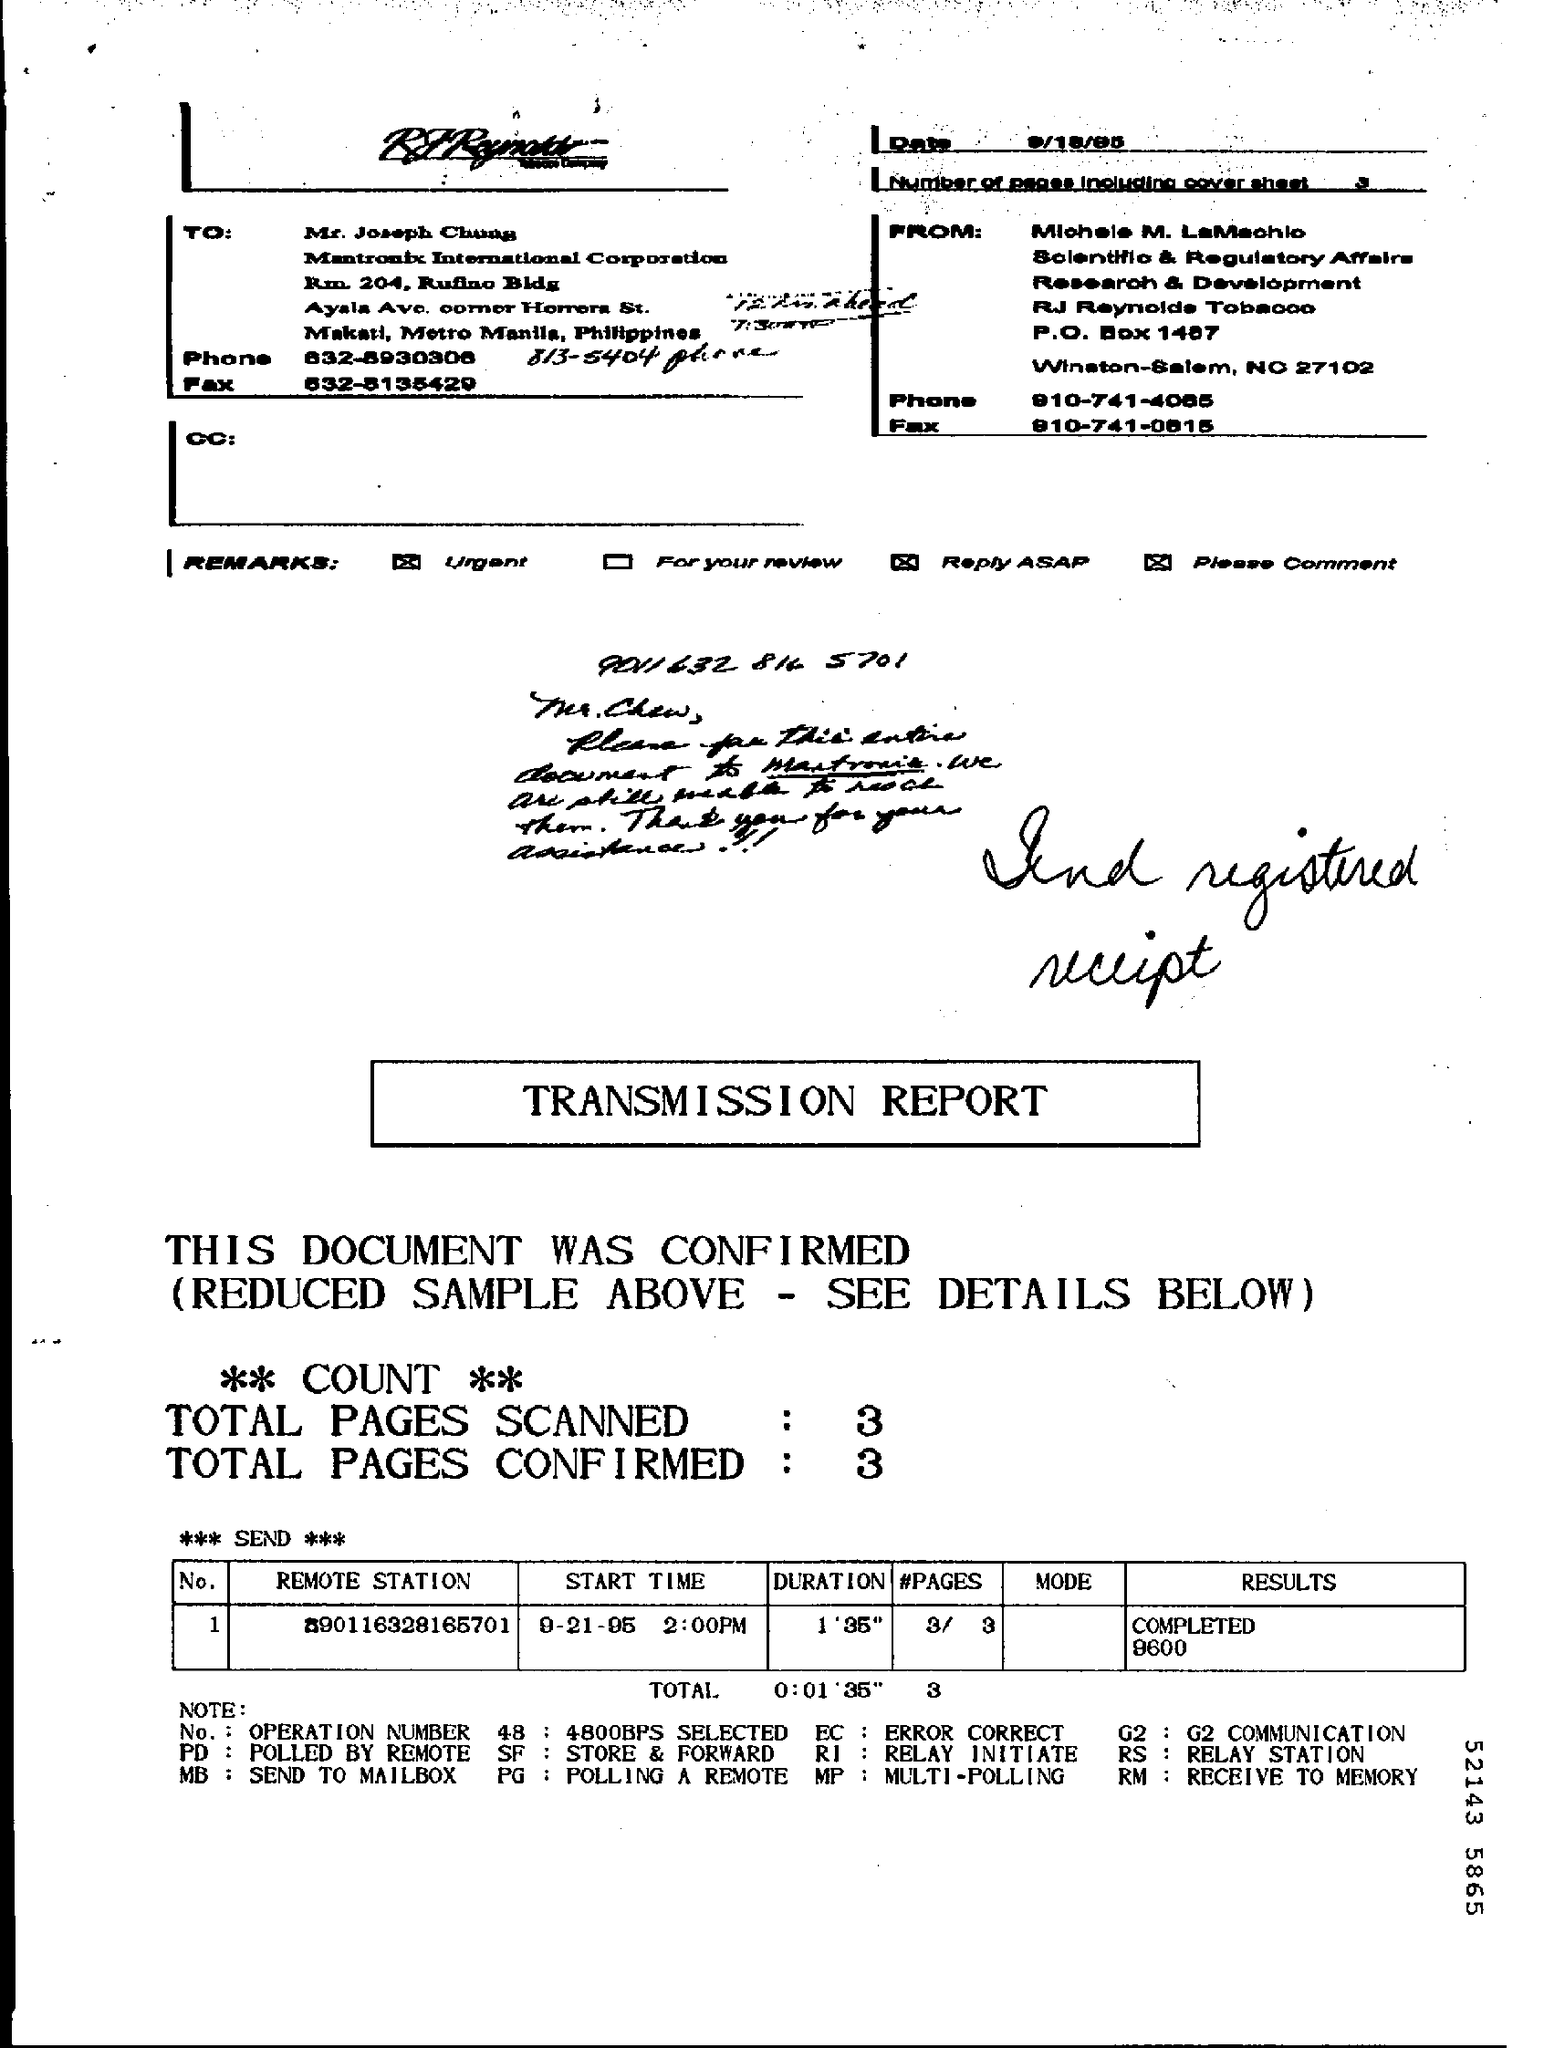What is the "Start Time"?
Make the answer very short. 9-21-95  2:00PM. What is the "Duration"?
Offer a terse response. 1'35". What are the Total Pages Scanned?
Your answer should be compact. 3. What are the Total Pages Confirmed?
Offer a terse response. 3. 